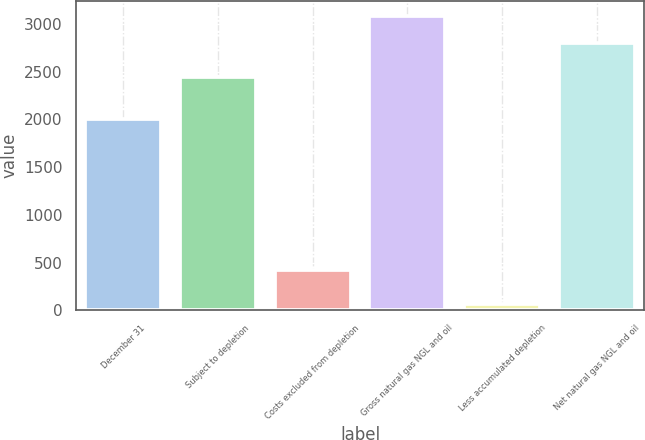<chart> <loc_0><loc_0><loc_500><loc_500><bar_chart><fcel>December 31<fcel>Subject to depletion<fcel>Costs excluded from depletion<fcel>Gross natural gas NGL and oil<fcel>Less accumulated depletion<fcel>Net natural gas NGL and oil<nl><fcel>2007<fcel>2443<fcel>426<fcel>3087.7<fcel>62<fcel>2807<nl></chart> 